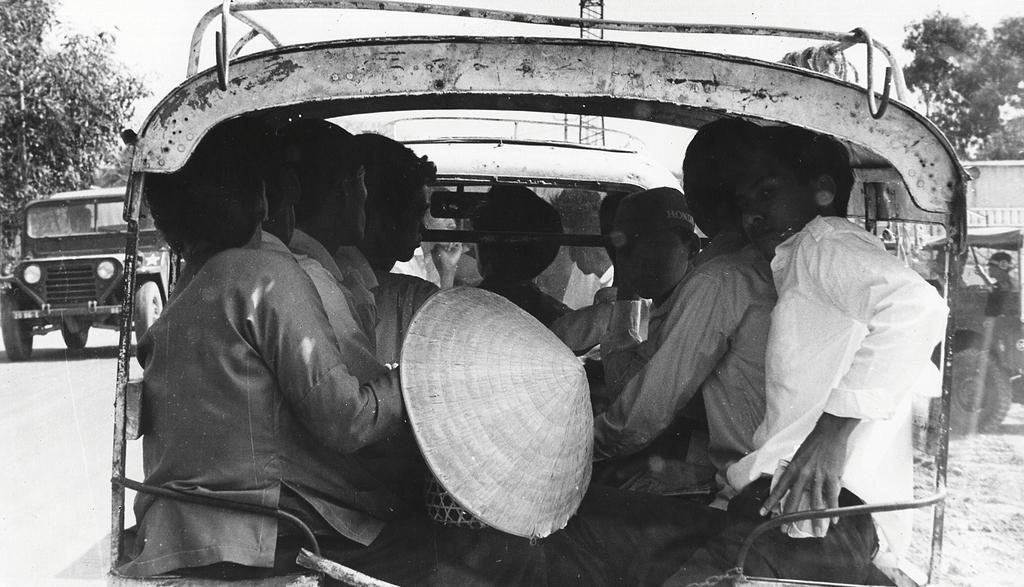Could you give a brief overview of what you see in this image? This is a black and white picture. There are vehicles on the road. Here we can see few persons inside a vehicle. In the background there are trees and sky. 